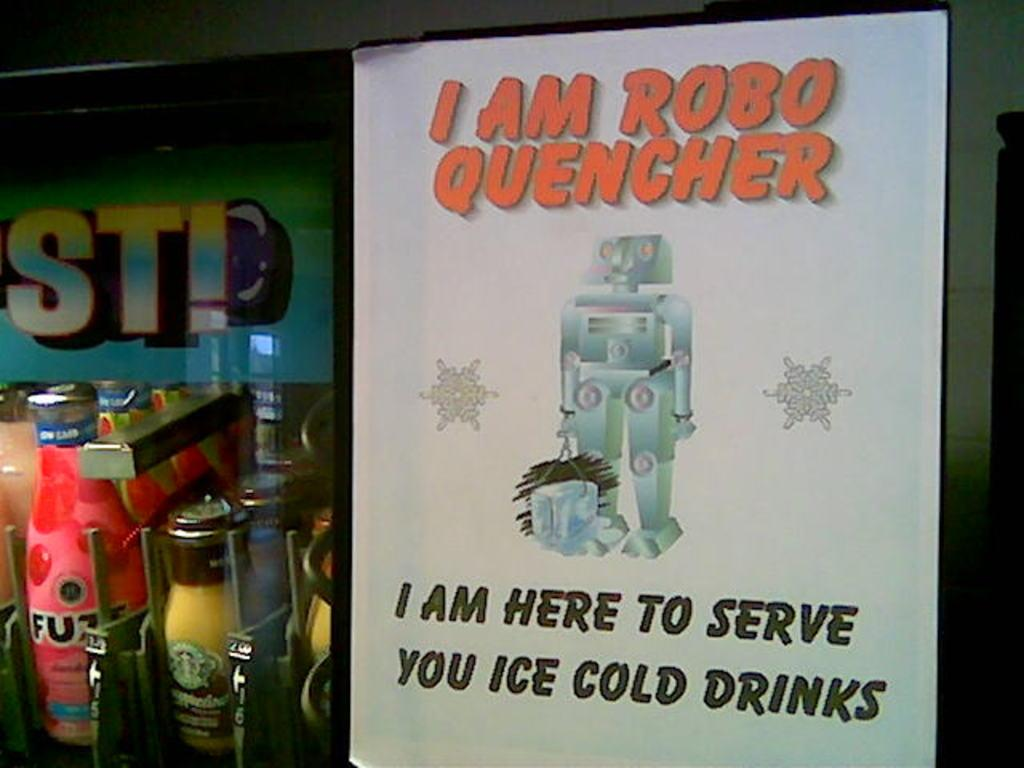<image>
Provide a brief description of the given image. A sign shows a robot that states, "I am here to serve you ice cold drinks." 